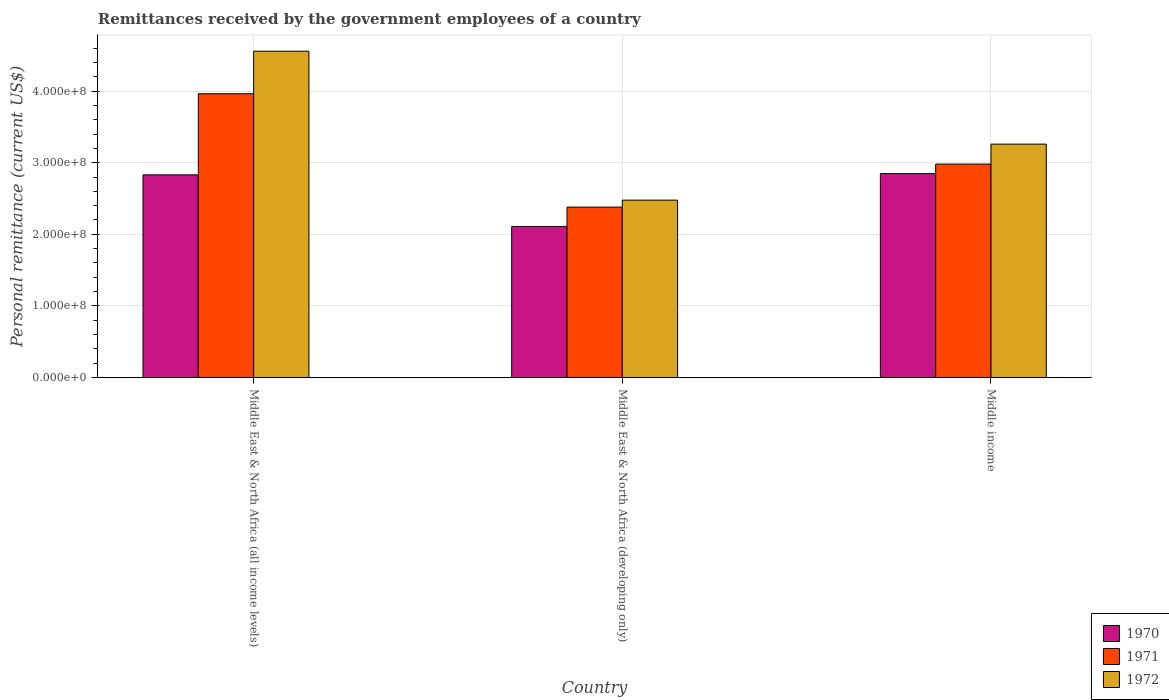How many groups of bars are there?
Make the answer very short. 3. Are the number of bars on each tick of the X-axis equal?
Your response must be concise. Yes. What is the label of the 3rd group of bars from the left?
Offer a very short reply. Middle income. In how many cases, is the number of bars for a given country not equal to the number of legend labels?
Provide a short and direct response. 0. What is the remittances received by the government employees in 1971 in Middle East & North Africa (developing only)?
Ensure brevity in your answer.  2.38e+08. Across all countries, what is the maximum remittances received by the government employees in 1970?
Your response must be concise. 2.85e+08. Across all countries, what is the minimum remittances received by the government employees in 1972?
Your response must be concise. 2.48e+08. In which country was the remittances received by the government employees in 1971 maximum?
Your answer should be compact. Middle East & North Africa (all income levels). In which country was the remittances received by the government employees in 1972 minimum?
Your answer should be compact. Middle East & North Africa (developing only). What is the total remittances received by the government employees in 1970 in the graph?
Keep it short and to the point. 7.79e+08. What is the difference between the remittances received by the government employees in 1970 in Middle East & North Africa (developing only) and that in Middle income?
Keep it short and to the point. -7.38e+07. What is the difference between the remittances received by the government employees in 1970 in Middle income and the remittances received by the government employees in 1971 in Middle East & North Africa (developing only)?
Your answer should be compact. 4.68e+07. What is the average remittances received by the government employees in 1970 per country?
Keep it short and to the point. 2.60e+08. What is the difference between the remittances received by the government employees of/in 1972 and remittances received by the government employees of/in 1971 in Middle income?
Keep it short and to the point. 2.79e+07. What is the ratio of the remittances received by the government employees in 1972 in Middle East & North Africa (all income levels) to that in Middle East & North Africa (developing only)?
Keep it short and to the point. 1.84. What is the difference between the highest and the second highest remittances received by the government employees in 1971?
Provide a short and direct response. -6.00e+07. What is the difference between the highest and the lowest remittances received by the government employees in 1972?
Offer a very short reply. 2.08e+08. Is the sum of the remittances received by the government employees in 1972 in Middle East & North Africa (all income levels) and Middle income greater than the maximum remittances received by the government employees in 1971 across all countries?
Your answer should be compact. Yes. What does the 2nd bar from the left in Middle income represents?
Provide a succinct answer. 1971. What does the 2nd bar from the right in Middle income represents?
Offer a very short reply. 1971. Is it the case that in every country, the sum of the remittances received by the government employees in 1972 and remittances received by the government employees in 1970 is greater than the remittances received by the government employees in 1971?
Your answer should be very brief. Yes. Are all the bars in the graph horizontal?
Ensure brevity in your answer.  No. Are the values on the major ticks of Y-axis written in scientific E-notation?
Your response must be concise. Yes. Does the graph contain grids?
Provide a succinct answer. Yes. Where does the legend appear in the graph?
Provide a succinct answer. Bottom right. What is the title of the graph?
Your response must be concise. Remittances received by the government employees of a country. What is the label or title of the X-axis?
Offer a very short reply. Country. What is the label or title of the Y-axis?
Give a very brief answer. Personal remittance (current US$). What is the Personal remittance (current US$) in 1970 in Middle East & North Africa (all income levels)?
Your response must be concise. 2.83e+08. What is the Personal remittance (current US$) in 1971 in Middle East & North Africa (all income levels)?
Make the answer very short. 3.96e+08. What is the Personal remittance (current US$) of 1972 in Middle East & North Africa (all income levels)?
Offer a very short reply. 4.56e+08. What is the Personal remittance (current US$) in 1970 in Middle East & North Africa (developing only)?
Offer a terse response. 2.11e+08. What is the Personal remittance (current US$) of 1971 in Middle East & North Africa (developing only)?
Provide a short and direct response. 2.38e+08. What is the Personal remittance (current US$) in 1972 in Middle East & North Africa (developing only)?
Ensure brevity in your answer.  2.48e+08. What is the Personal remittance (current US$) in 1970 in Middle income?
Make the answer very short. 2.85e+08. What is the Personal remittance (current US$) of 1971 in Middle income?
Give a very brief answer. 2.98e+08. What is the Personal remittance (current US$) of 1972 in Middle income?
Give a very brief answer. 3.26e+08. Across all countries, what is the maximum Personal remittance (current US$) in 1970?
Offer a very short reply. 2.85e+08. Across all countries, what is the maximum Personal remittance (current US$) of 1971?
Give a very brief answer. 3.96e+08. Across all countries, what is the maximum Personal remittance (current US$) in 1972?
Offer a very short reply. 4.56e+08. Across all countries, what is the minimum Personal remittance (current US$) of 1970?
Ensure brevity in your answer.  2.11e+08. Across all countries, what is the minimum Personal remittance (current US$) of 1971?
Provide a short and direct response. 2.38e+08. Across all countries, what is the minimum Personal remittance (current US$) of 1972?
Ensure brevity in your answer.  2.48e+08. What is the total Personal remittance (current US$) in 1970 in the graph?
Your answer should be very brief. 7.79e+08. What is the total Personal remittance (current US$) of 1971 in the graph?
Your response must be concise. 9.32e+08. What is the total Personal remittance (current US$) of 1972 in the graph?
Your response must be concise. 1.03e+09. What is the difference between the Personal remittance (current US$) of 1970 in Middle East & North Africa (all income levels) and that in Middle East & North Africa (developing only)?
Your response must be concise. 7.20e+07. What is the difference between the Personal remittance (current US$) of 1971 in Middle East & North Africa (all income levels) and that in Middle East & North Africa (developing only)?
Ensure brevity in your answer.  1.58e+08. What is the difference between the Personal remittance (current US$) in 1972 in Middle East & North Africa (all income levels) and that in Middle East & North Africa (developing only)?
Your response must be concise. 2.08e+08. What is the difference between the Personal remittance (current US$) of 1970 in Middle East & North Africa (all income levels) and that in Middle income?
Your answer should be very brief. -1.76e+06. What is the difference between the Personal remittance (current US$) in 1971 in Middle East & North Africa (all income levels) and that in Middle income?
Provide a succinct answer. 9.82e+07. What is the difference between the Personal remittance (current US$) of 1972 in Middle East & North Africa (all income levels) and that in Middle income?
Keep it short and to the point. 1.30e+08. What is the difference between the Personal remittance (current US$) of 1970 in Middle East & North Africa (developing only) and that in Middle income?
Offer a very short reply. -7.38e+07. What is the difference between the Personal remittance (current US$) in 1971 in Middle East & North Africa (developing only) and that in Middle income?
Give a very brief answer. -6.00e+07. What is the difference between the Personal remittance (current US$) of 1972 in Middle East & North Africa (developing only) and that in Middle income?
Keep it short and to the point. -7.81e+07. What is the difference between the Personal remittance (current US$) in 1970 in Middle East & North Africa (all income levels) and the Personal remittance (current US$) in 1971 in Middle East & North Africa (developing only)?
Make the answer very short. 4.50e+07. What is the difference between the Personal remittance (current US$) of 1970 in Middle East & North Africa (all income levels) and the Personal remittance (current US$) of 1972 in Middle East & North Africa (developing only)?
Ensure brevity in your answer.  3.53e+07. What is the difference between the Personal remittance (current US$) of 1971 in Middle East & North Africa (all income levels) and the Personal remittance (current US$) of 1972 in Middle East & North Africa (developing only)?
Keep it short and to the point. 1.48e+08. What is the difference between the Personal remittance (current US$) of 1970 in Middle East & North Africa (all income levels) and the Personal remittance (current US$) of 1971 in Middle income?
Your response must be concise. -1.50e+07. What is the difference between the Personal remittance (current US$) in 1970 in Middle East & North Africa (all income levels) and the Personal remittance (current US$) in 1972 in Middle income?
Give a very brief answer. -4.29e+07. What is the difference between the Personal remittance (current US$) of 1971 in Middle East & North Africa (all income levels) and the Personal remittance (current US$) of 1972 in Middle income?
Your response must be concise. 7.03e+07. What is the difference between the Personal remittance (current US$) of 1970 in Middle East & North Africa (developing only) and the Personal remittance (current US$) of 1971 in Middle income?
Give a very brief answer. -8.70e+07. What is the difference between the Personal remittance (current US$) in 1970 in Middle East & North Africa (developing only) and the Personal remittance (current US$) in 1972 in Middle income?
Your answer should be very brief. -1.15e+08. What is the difference between the Personal remittance (current US$) of 1971 in Middle East & North Africa (developing only) and the Personal remittance (current US$) of 1972 in Middle income?
Ensure brevity in your answer.  -8.79e+07. What is the average Personal remittance (current US$) of 1970 per country?
Your answer should be very brief. 2.60e+08. What is the average Personal remittance (current US$) in 1971 per country?
Offer a very short reply. 3.11e+08. What is the average Personal remittance (current US$) of 1972 per country?
Your answer should be compact. 3.43e+08. What is the difference between the Personal remittance (current US$) of 1970 and Personal remittance (current US$) of 1971 in Middle East & North Africa (all income levels)?
Your answer should be very brief. -1.13e+08. What is the difference between the Personal remittance (current US$) in 1970 and Personal remittance (current US$) in 1972 in Middle East & North Africa (all income levels)?
Ensure brevity in your answer.  -1.73e+08. What is the difference between the Personal remittance (current US$) of 1971 and Personal remittance (current US$) of 1972 in Middle East & North Africa (all income levels)?
Your answer should be very brief. -5.94e+07. What is the difference between the Personal remittance (current US$) of 1970 and Personal remittance (current US$) of 1971 in Middle East & North Africa (developing only)?
Keep it short and to the point. -2.70e+07. What is the difference between the Personal remittance (current US$) of 1970 and Personal remittance (current US$) of 1972 in Middle East & North Africa (developing only)?
Make the answer very short. -3.67e+07. What is the difference between the Personal remittance (current US$) of 1971 and Personal remittance (current US$) of 1972 in Middle East & North Africa (developing only)?
Ensure brevity in your answer.  -9.72e+06. What is the difference between the Personal remittance (current US$) in 1970 and Personal remittance (current US$) in 1971 in Middle income?
Offer a very short reply. -1.32e+07. What is the difference between the Personal remittance (current US$) in 1970 and Personal remittance (current US$) in 1972 in Middle income?
Ensure brevity in your answer.  -4.11e+07. What is the difference between the Personal remittance (current US$) of 1971 and Personal remittance (current US$) of 1972 in Middle income?
Offer a very short reply. -2.79e+07. What is the ratio of the Personal remittance (current US$) of 1970 in Middle East & North Africa (all income levels) to that in Middle East & North Africa (developing only)?
Provide a short and direct response. 1.34. What is the ratio of the Personal remittance (current US$) of 1971 in Middle East & North Africa (all income levels) to that in Middle East & North Africa (developing only)?
Provide a short and direct response. 1.66. What is the ratio of the Personal remittance (current US$) of 1972 in Middle East & North Africa (all income levels) to that in Middle East & North Africa (developing only)?
Offer a terse response. 1.84. What is the ratio of the Personal remittance (current US$) of 1971 in Middle East & North Africa (all income levels) to that in Middle income?
Offer a terse response. 1.33. What is the ratio of the Personal remittance (current US$) of 1972 in Middle East & North Africa (all income levels) to that in Middle income?
Your answer should be compact. 1.4. What is the ratio of the Personal remittance (current US$) of 1970 in Middle East & North Africa (developing only) to that in Middle income?
Ensure brevity in your answer.  0.74. What is the ratio of the Personal remittance (current US$) in 1971 in Middle East & North Africa (developing only) to that in Middle income?
Provide a short and direct response. 0.8. What is the ratio of the Personal remittance (current US$) of 1972 in Middle East & North Africa (developing only) to that in Middle income?
Your response must be concise. 0.76. What is the difference between the highest and the second highest Personal remittance (current US$) of 1970?
Your answer should be compact. 1.76e+06. What is the difference between the highest and the second highest Personal remittance (current US$) in 1971?
Offer a very short reply. 9.82e+07. What is the difference between the highest and the second highest Personal remittance (current US$) in 1972?
Make the answer very short. 1.30e+08. What is the difference between the highest and the lowest Personal remittance (current US$) of 1970?
Keep it short and to the point. 7.38e+07. What is the difference between the highest and the lowest Personal remittance (current US$) of 1971?
Your response must be concise. 1.58e+08. What is the difference between the highest and the lowest Personal remittance (current US$) in 1972?
Offer a very short reply. 2.08e+08. 